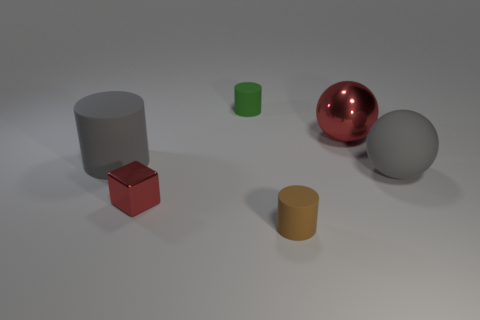What number of other things are the same color as the big shiny object?
Offer a terse response. 1. There is a green object; are there any small brown cylinders in front of it?
Keep it short and to the point. Yes. How many things are either green shiny things or tiny objects that are behind the rubber sphere?
Your answer should be compact. 1. There is a gray object behind the gray ball; is there a big gray cylinder in front of it?
Your response must be concise. No. There is a big red shiny thing that is left of the big gray object to the right of the small object behind the red ball; what is its shape?
Make the answer very short. Sphere. What color is the thing that is behind the gray cylinder and in front of the small green matte cylinder?
Give a very brief answer. Red. There is a large gray rubber thing to the right of the tiny green object; what shape is it?
Provide a short and direct response. Sphere. There is a small object that is made of the same material as the tiny brown cylinder; what is its shape?
Provide a short and direct response. Cylinder. How many shiny objects are either big purple blocks or big gray spheres?
Offer a terse response. 0. How many large gray matte spheres are to the right of the big gray object that is on the right side of the matte cylinder that is behind the red sphere?
Your response must be concise. 0. 